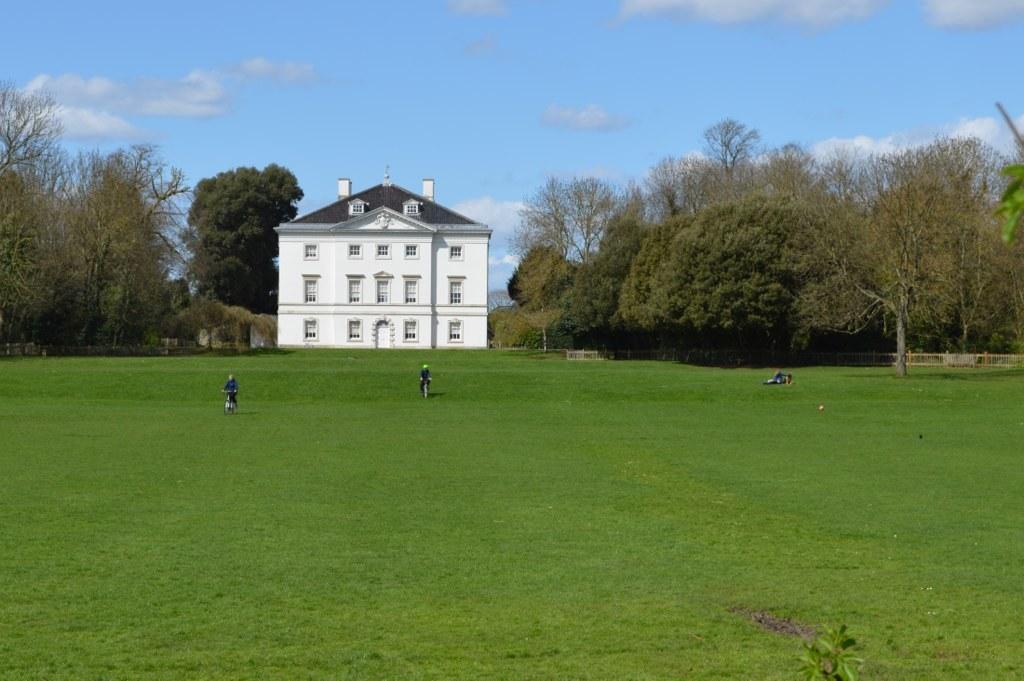How would you summarize this image in a sentence or two? In this image there is a white colour building with the windows in the middle. There are trees on either side of the building. In front of the building there is a ground on which there are two persons cycling on it. At the top there is sky. 